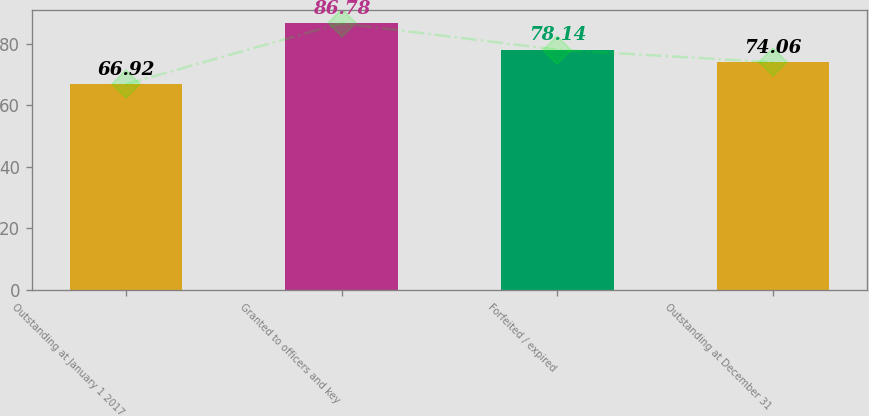Convert chart. <chart><loc_0><loc_0><loc_500><loc_500><bar_chart><fcel>Outstanding at January 1 2017<fcel>Granted to officers and key<fcel>Forfeited / expired<fcel>Outstanding at December 31<nl><fcel>66.92<fcel>86.78<fcel>78.14<fcel>74.06<nl></chart> 